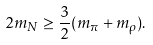<formula> <loc_0><loc_0><loc_500><loc_500>2 m _ { N } \geq \frac { 3 } { 2 } ( m _ { \pi } + m _ { \rho } ) .</formula> 